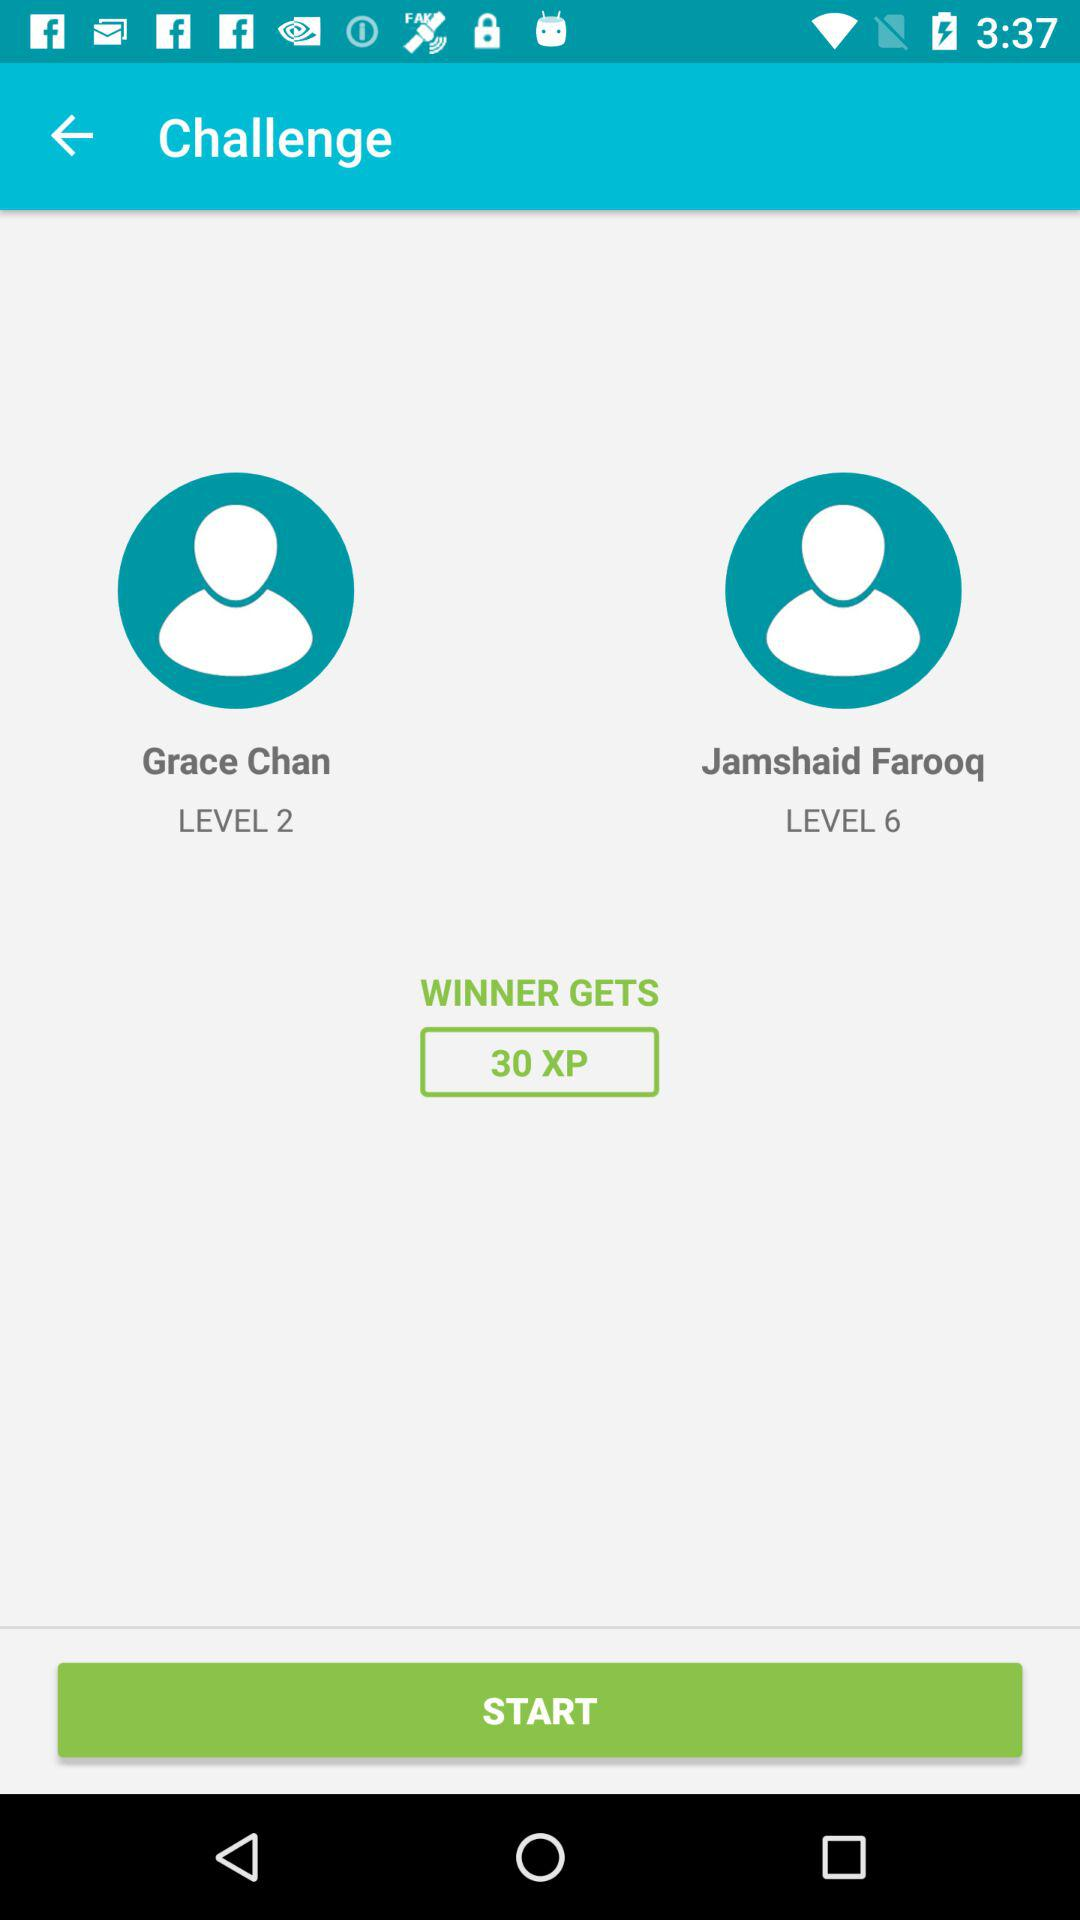What is the level of Grace Chan? The level of Grace Chan is 2. 